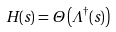Convert formula to latex. <formula><loc_0><loc_0><loc_500><loc_500>H ( s ) = \Theta \left ( \Lambda ^ { \dagger } ( s ) \right )</formula> 